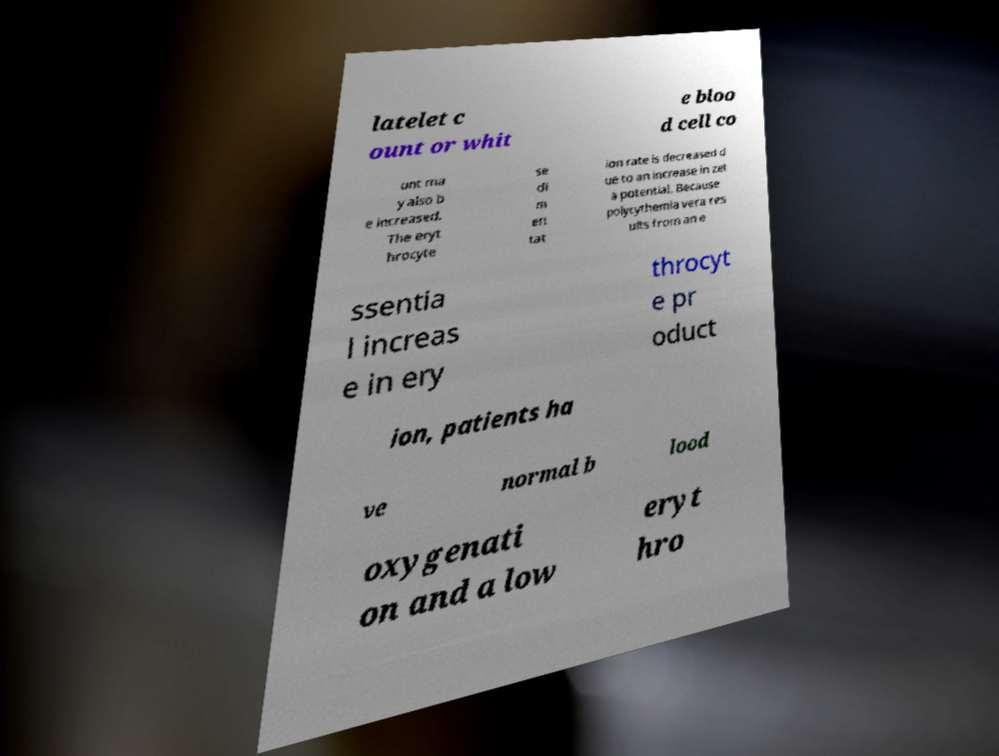What messages or text are displayed in this image? I need them in a readable, typed format. latelet c ount or whit e bloo d cell co unt ma y also b e increased. The eryt hrocyte se di m en tat ion rate is decreased d ue to an increase in zet a potential. Because polycythemia vera res ults from an e ssentia l increas e in ery throcyt e pr oduct ion, patients ha ve normal b lood oxygenati on and a low eryt hro 